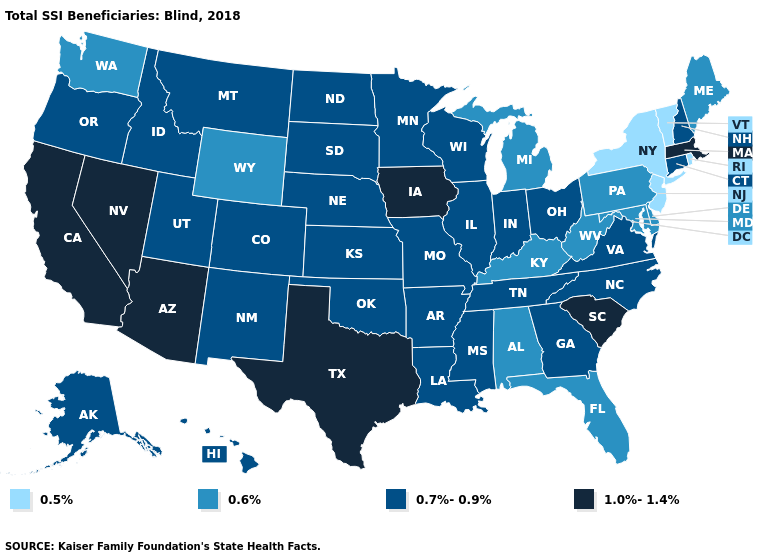What is the value of Florida?
Give a very brief answer. 0.6%. What is the lowest value in states that border Mississippi?
Write a very short answer. 0.6%. How many symbols are there in the legend?
Concise answer only. 4. What is the highest value in states that border New Jersey?
Keep it brief. 0.6%. Is the legend a continuous bar?
Short answer required. No. Does Connecticut have a higher value than Missouri?
Concise answer only. No. Among the states that border Indiana , does Kentucky have the highest value?
Be succinct. No. What is the lowest value in states that border Nebraska?
Answer briefly. 0.6%. Name the states that have a value in the range 0.6%?
Be succinct. Alabama, Delaware, Florida, Kentucky, Maine, Maryland, Michigan, Pennsylvania, Washington, West Virginia, Wyoming. Name the states that have a value in the range 1.0%-1.4%?
Concise answer only. Arizona, California, Iowa, Massachusetts, Nevada, South Carolina, Texas. Which states have the lowest value in the South?
Quick response, please. Alabama, Delaware, Florida, Kentucky, Maryland, West Virginia. Name the states that have a value in the range 0.5%?
Answer briefly. New Jersey, New York, Rhode Island, Vermont. Which states hav the highest value in the MidWest?
Concise answer only. Iowa. Name the states that have a value in the range 0.7%-0.9%?
Answer briefly. Alaska, Arkansas, Colorado, Connecticut, Georgia, Hawaii, Idaho, Illinois, Indiana, Kansas, Louisiana, Minnesota, Mississippi, Missouri, Montana, Nebraska, New Hampshire, New Mexico, North Carolina, North Dakota, Ohio, Oklahoma, Oregon, South Dakota, Tennessee, Utah, Virginia, Wisconsin. 